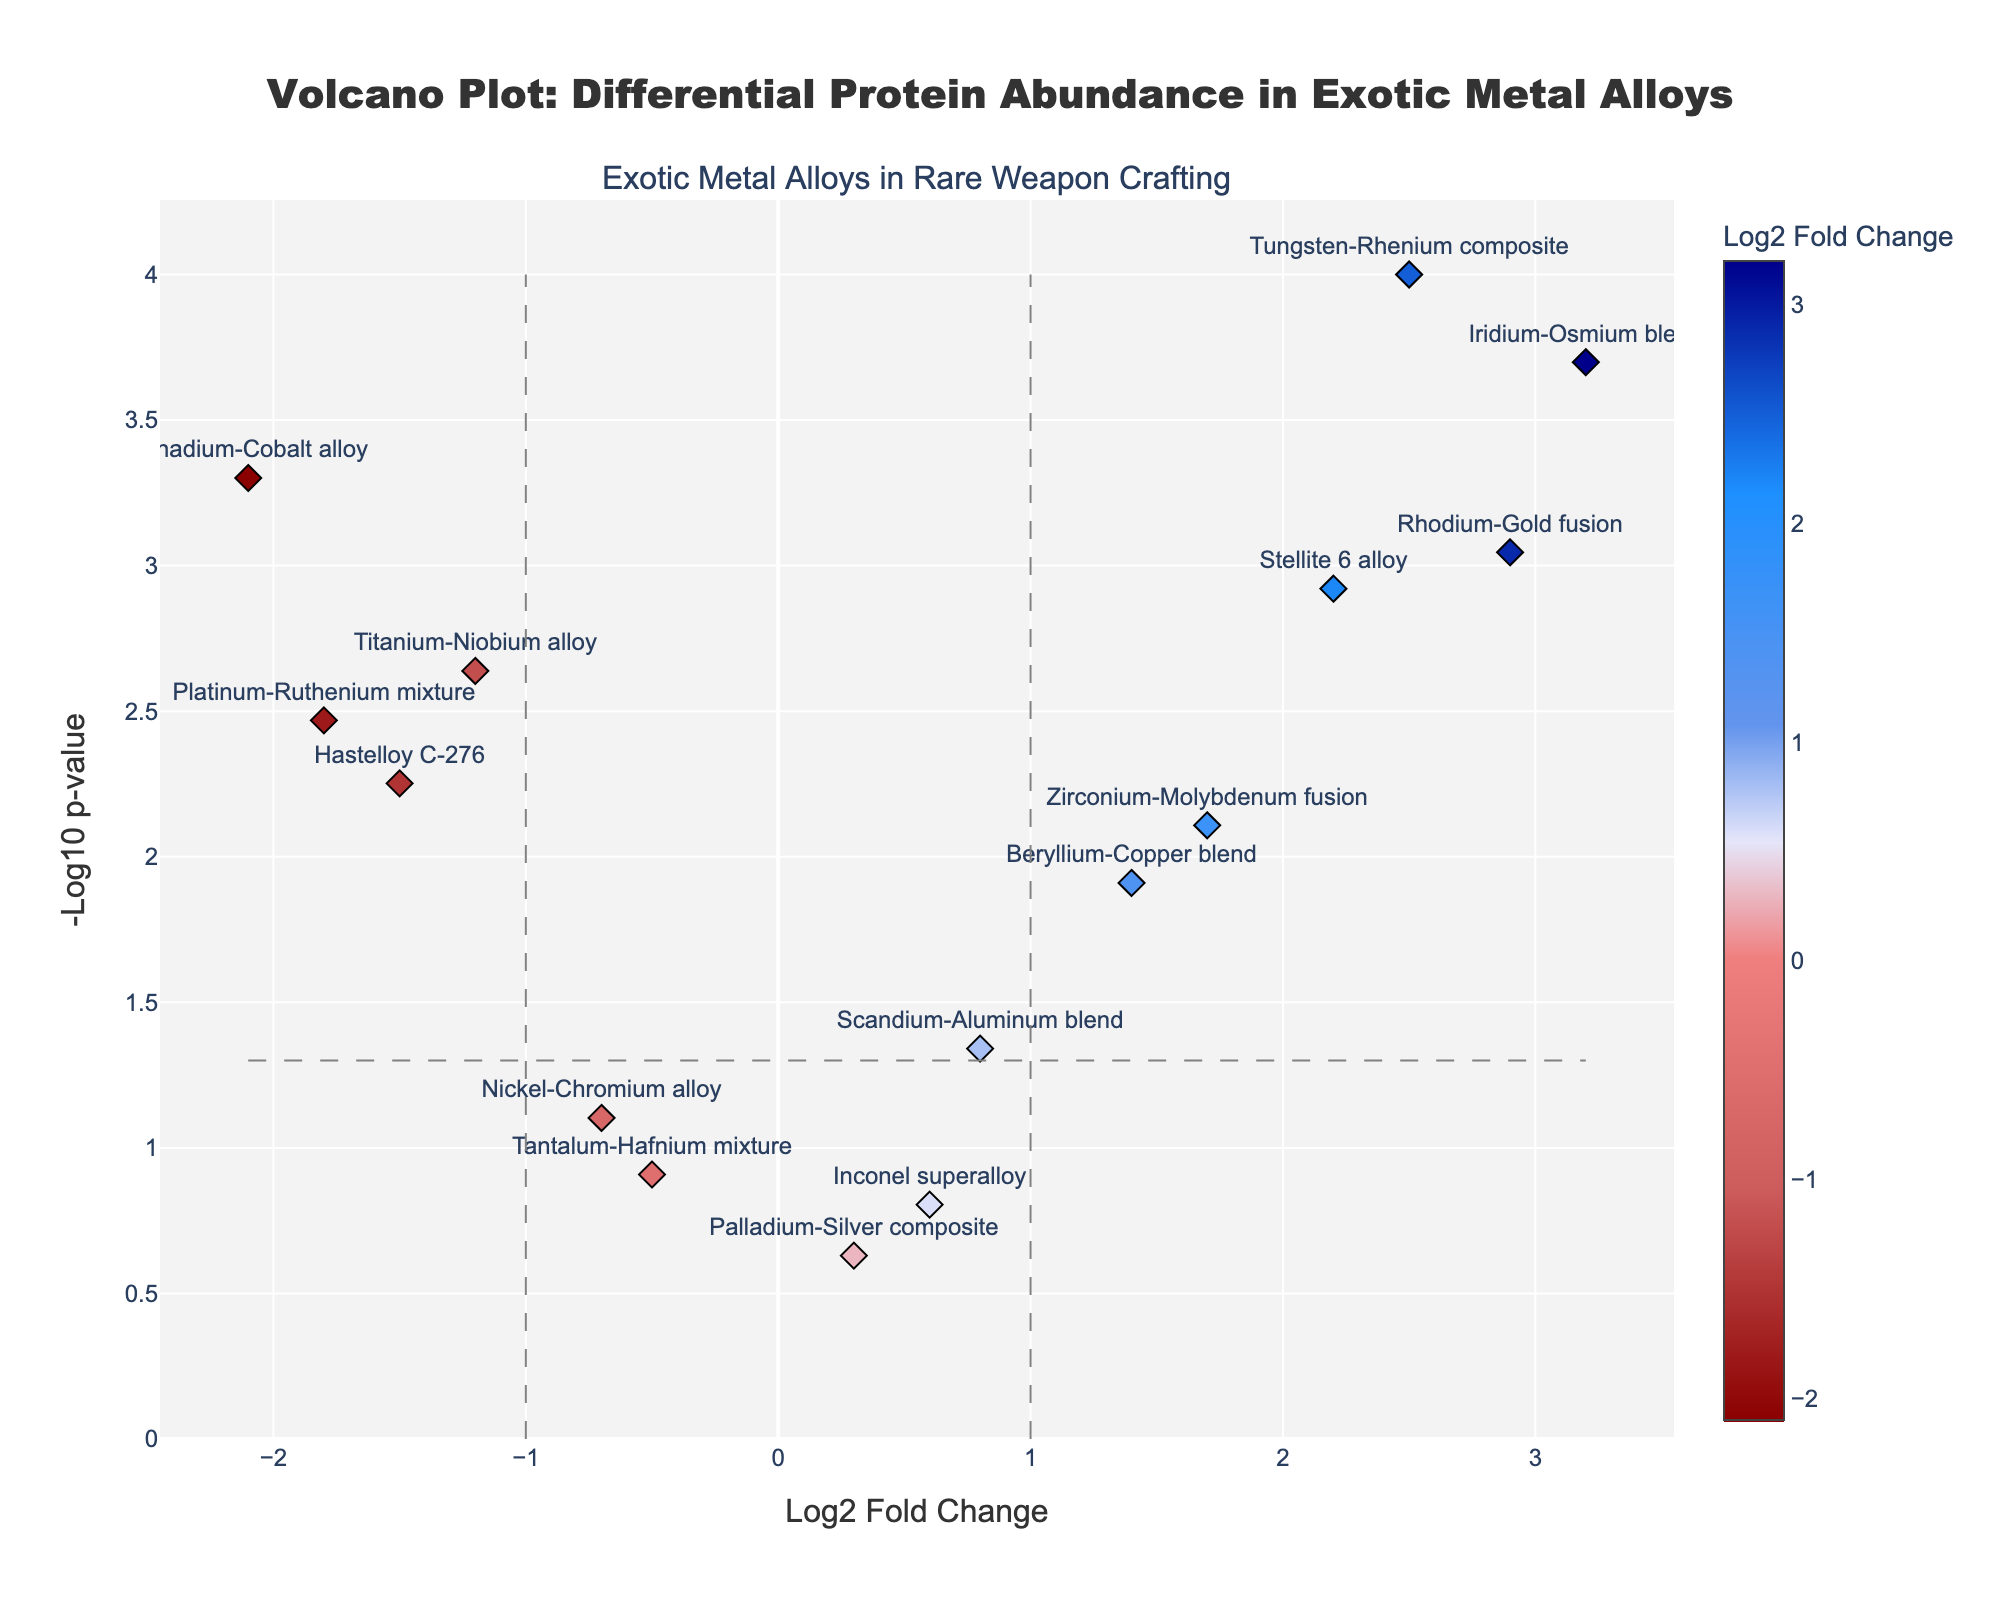What is the title of the plot? The title of the plot is displayed at the top of the figure, which reads "Volcano Plot: Differential Protein Abundance in Exotic Metal Alloys".
Answer: Volcano Plot: Differential Protein Abundance in Exotic Metal Alloys How many data points have a Log2 Fold Change greater than 2? By observing the horizontal axis (Log2 Fold Change) and counting the data points to the right of the value 2, we find that there are three points: Tungsten-Rhenium composite, Iridium-Osmium blend, and Rhodium-Gold fusion.
Answer: 3 Which alloy has the most extreme negative Log2 Fold Change? By examining the horizontal axis for the lowest Log2 Fold Change value, Vanadium-Cobalt alloy has the most extreme negative value with a Log2 Fold Change of -2.1.
Answer: Vanadium-Cobalt alloy What are the log2 fold change and p-value of the Beryllium-Copper blend? Hover over or find the Beryllium-Copper blend in the figure, which shows a log2 fold change of 1.4 and a p-value of 0.0123.
Answer: 1.4, 0.0123 Which data point is closest to the horizontal line representing a p-value of 0.05? The horizontal line at -log10(0.05) corresponds to a value of 1.3 on the vertical axis. The data point closest to this line is the Beryllium-Copper blend with a -log10 p-value just above 1.3.
Answer: Beryllium-Copper blend Between the Rhodium-Gold fusion and the Inconel superalloy, which has a higher -log10 p-value? Observing the vertical axis for both alloys, the Rhodium-Gold fusion has a significantly higher value than the Inconel superalloy.
Answer: Rhodium-Gold fusion Which alloy has a higher p-value: Palladium-Silver composite or Nickel-Chromium alloy? Looking at the vertical axis, the Palladium-Silver composite is higher than the Nickel-Chromium alloy, indicating that the Palladium-Silver composite has a higher p-value (0.2345 compared to 0.0789).
Answer: Palladium-Silver composite How many alloys have a -log10 p-value greater than 2? Counting the data points above the vertical value 2 on the y-axis, we have four alloys: Tungsten-Rhenium composite, Iridium-Osmium blend, Vanadium-Cobalt alloy, and Rhodium-Gold fusion.
Answer: 4 Which alloy lies closest to the origin (0,0) in the plot? The origin is at (0,0) on the axes. The point closest to it visually is the Palladium-Silver composite with a log2 fold change of 0.3 and a -log10 p-value less than 0.5.
Answer: Palladium-Silver composite 